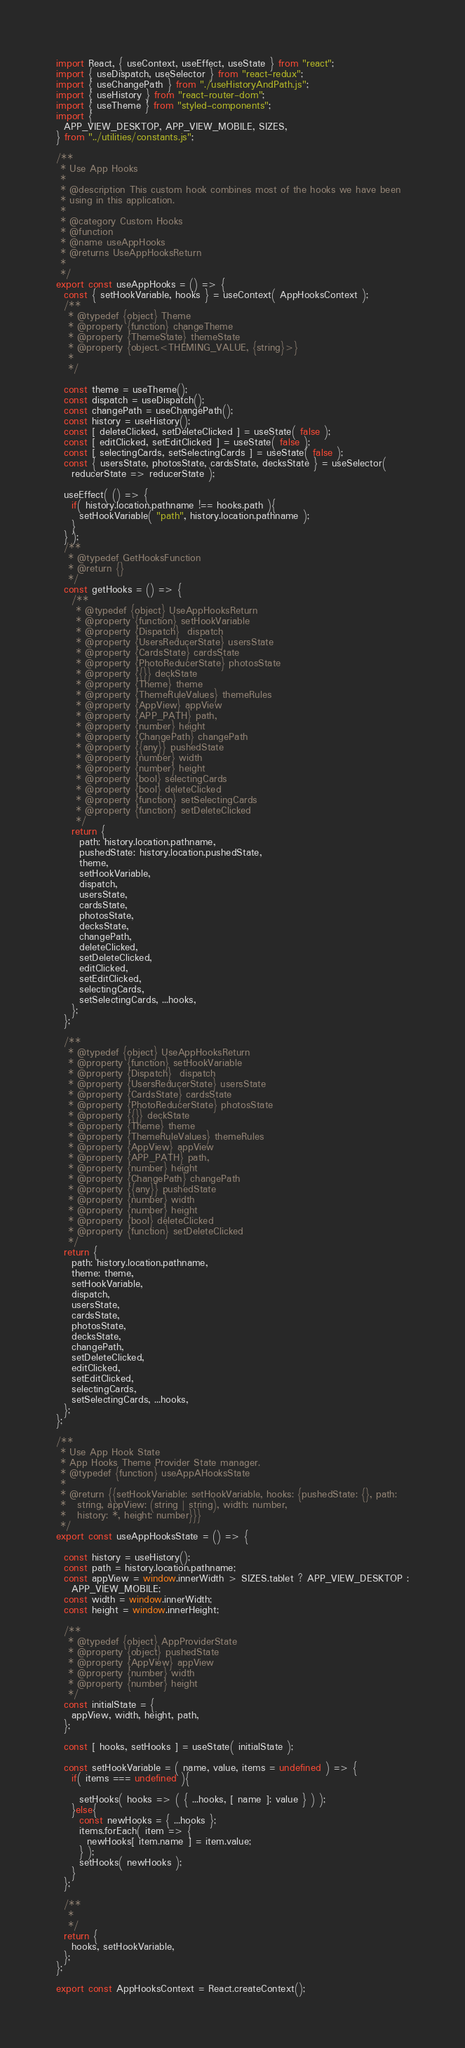Convert code to text. <code><loc_0><loc_0><loc_500><loc_500><_JavaScript_>import React, { useContext, useEffect, useState } from "react";
import { useDispatch, useSelector } from "react-redux";
import { useChangePath } from "./useHistoryAndPath.js";
import { useHistory } from "react-router-dom";
import { useTheme } from "styled-components";
import {
  APP_VIEW_DESKTOP, APP_VIEW_MOBILE, SIZES,
} from "../utilities/constants.js";

/**
 * Use App Hooks
 *
 * @description This custom hook combines most of the hooks we have been
 * using in this application.
 *
 * @category Custom Hooks
 * @function
 * @name useAppHooks
 * @returns UseAppHooksReturn
 *
 */
export const useAppHooks = () => {
  const { setHookVariable, hooks } = useContext( AppHooksContext );
  /**
   * @typedef {object} Theme
   * @property {function} changeTheme
   * @property {ThemeState} themeState
   * @property {object.<THEMING_VALUE, {string}>}
   *
   */
  
  const theme = useTheme();
  const dispatch = useDispatch();
  const changePath = useChangePath();
  const history = useHistory();
  const [ deleteClicked, setDeleteClicked ] = useState( false );
  const [ editClicked, setEditClicked ] = useState( false );
  const [ selectingCards, setSelectingCards ] = useState( false );
  const { usersState, photosState, cardsState, decksState } = useSelector(
    reducerState => reducerState );
  
  useEffect( () => {
    if( history.location.pathname !== hooks.path ){
      setHookVariable( "path", history.location.pathname );
    }
  } );
  /**
   * @typedef GetHooksFunction
   * @return {}
   */
  const getHooks = () => {
    /**
     * @typedef {object} UseAppHooksReturn
     * @property {function} setHookVariable
     * @property {Dispatch}  dispatch
     * @property {UsersReducerState} usersState
     * @property {CardsState} cardsState
     * @property {PhotoReducerState} photosState
     * @property {{}} deckState
     * @property {Theme} theme
     * @property {ThemeRuleValues} themeRules
     * @property {AppView} appView
     * @property {APP_PATH} path,
     * @property {number} height
     * @property {ChangePath} changePath
     * @property {{any}} pushedState
     * @property {number} width
     * @property {number} height
     * @property {bool} selectingCards
     * @property {bool} deleteClicked
     * @property {function} setSelectingCards
     * @property {function} setDeleteClicked
     */
    return {
      path: history.location.pathname,
      pushedState: history.location.pushedState,
      theme,
      setHookVariable,
      dispatch,
      usersState,
      cardsState,
      photosState,
      decksState,
      changePath,
      deleteClicked,
      setDeleteClicked,
      editClicked,
      setEditClicked,
      selectingCards,
      setSelectingCards, ...hooks,
    };
  };
  
  /**
   * @typedef {object} UseAppHooksReturn
   * @property {function} setHookVariable
   * @property {Dispatch}  dispatch
   * @property {UsersReducerState} usersState
   * @property {CardsState} cardsState
   * @property {PhotoReducerState} photosState
   * @property {{}} deckState
   * @property {Theme} theme
   * @property {ThemeRuleValues} themeRules
   * @property {AppView} appView
   * @property {APP_PATH} path,
   * @property {number} height
   * @property {ChangePath} changePath
   * @property {{any}} pushedState
   * @property {number} width
   * @property {number} height
   * @property {bool} deleteClicked
   * @property {function} setDeleteClicked
   */
  return {
    path: history.location.pathname,
    theme: theme,
    setHookVariable,
    dispatch,
    usersState,
    cardsState,
    photosState,
    decksState,
    changePath,
    setDeleteClicked,
    editClicked,
    setEditClicked,
    selectingCards,
    setSelectingCards, ...hooks,
  };
};

/**
 * Use App Hook State
 * App Hooks Theme Provider State manager.
 * @typedef {function} useAppAHooksState
 *
 * @return {{setHookVariable: setHookVariable, hooks: {pushedState: {}, path:
 *   string, appView: (string | string), width: number,
 *   history: *, height: number}}}
 */
export const useAppHooksState = () => {
  
  const history = useHistory();
  const path = history.location.pathname;
  const appView = window.innerWidth > SIZES.tablet ? APP_VIEW_DESKTOP :
    APP_VIEW_MOBILE;
  const width = window.innerWidth;
  const height = window.innerHeight;
  
  /**
   * @typedef {object} AppProviderState
   * @property {object} pushedState
   * @property {AppView} appView
   * @property {number} width
   * @property {number} height
   */
  const initialState = {
    appView, width, height, path,
  };
  
  const [ hooks, setHooks ] = useState( initialState );
  
  const setHookVariable = ( name, value, items = undefined ) => {
    if( items === undefined ){
      
      setHooks( hooks => ( { ...hooks, [ name ]: value } ) );
    }else{
      const newHooks = { ...hooks };
      items.forEach( item => {
        newHooks[ item.name ] = item.value;
      } );
      setHooks( newHooks );
    }
  };
  
  /**
   *
   */
  return {
    hooks, setHookVariable,
  };
};

export const AppHooksContext = React.createContext();
</code> 